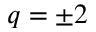<formula> <loc_0><loc_0><loc_500><loc_500>q = \pm 2</formula> 